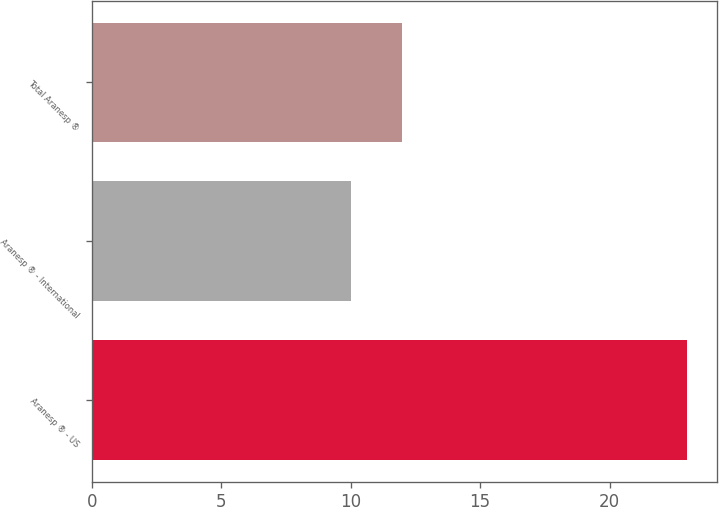Convert chart. <chart><loc_0><loc_0><loc_500><loc_500><bar_chart><fcel>Aranesp ® - US<fcel>Aranesp ® - International<fcel>Total Aranesp ®<nl><fcel>23<fcel>10<fcel>12<nl></chart> 